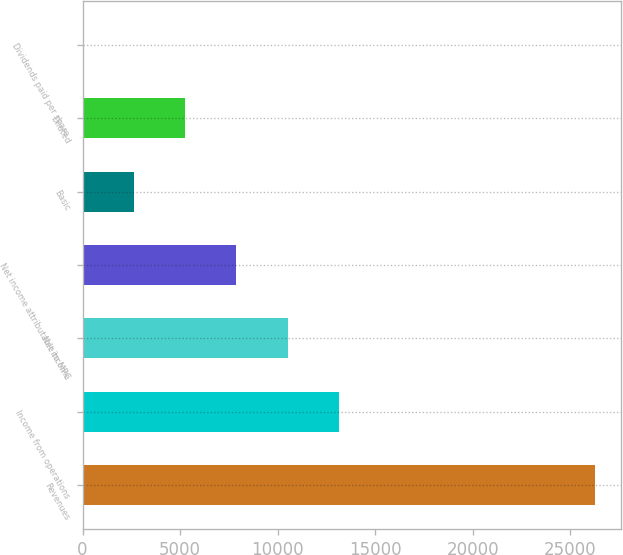Convert chart. <chart><loc_0><loc_0><loc_500><loc_500><bar_chart><fcel>Revenues<fcel>Income from operations<fcel>Net income<fcel>Net income attributable to MPC<fcel>Basic<fcel>Diluted<fcel>Dividends paid per share<nl><fcel>26256<fcel>13128.2<fcel>10502.7<fcel>7877.1<fcel>2625.98<fcel>5251.54<fcel>0.42<nl></chart> 